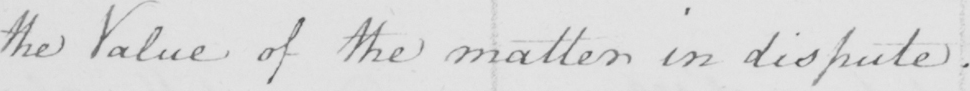Can you tell me what this handwritten text says? the Value of the matter in dispute . 